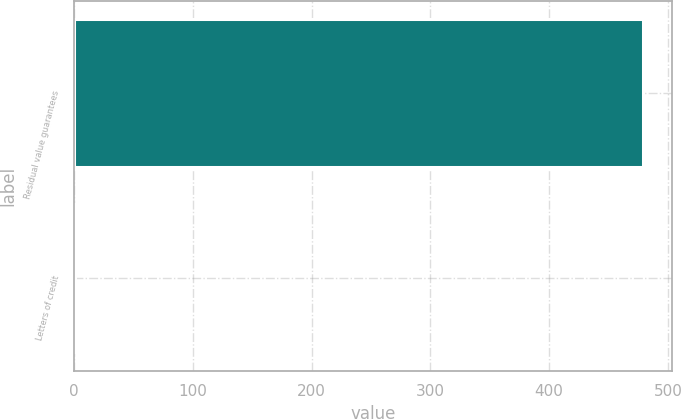Convert chart. <chart><loc_0><loc_0><loc_500><loc_500><bar_chart><fcel>Residual value guarantees<fcel>Letters of credit<nl><fcel>479.4<fcel>0.5<nl></chart> 